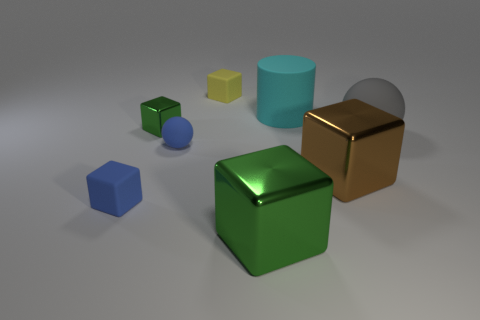Do the brown metallic object and the yellow matte thing behind the large gray rubber ball have the same shape?
Make the answer very short. Yes. What shape is the big shiny thing that is the same color as the small shiny block?
Give a very brief answer. Cube. The blue rubber object on the left side of the small ball has what shape?
Offer a terse response. Cube. There is a tiny blue matte object that is on the left side of the small green cube; is it the same shape as the brown thing?
Offer a very short reply. Yes. There is another thing that is the same shape as the gray thing; what is its color?
Offer a terse response. Blue. What is the size of the rubber ball in front of the gray matte ball?
Make the answer very short. Small. Is the color of the tiny ball the same as the small block that is in front of the brown cube?
Keep it short and to the point. Yes. What number of other objects are there of the same material as the large brown thing?
Your answer should be very brief. 2. Are there more big matte spheres than purple cubes?
Keep it short and to the point. Yes. There is a tiny block that is behind the big cyan cylinder; is its color the same as the big matte ball?
Offer a terse response. No. 